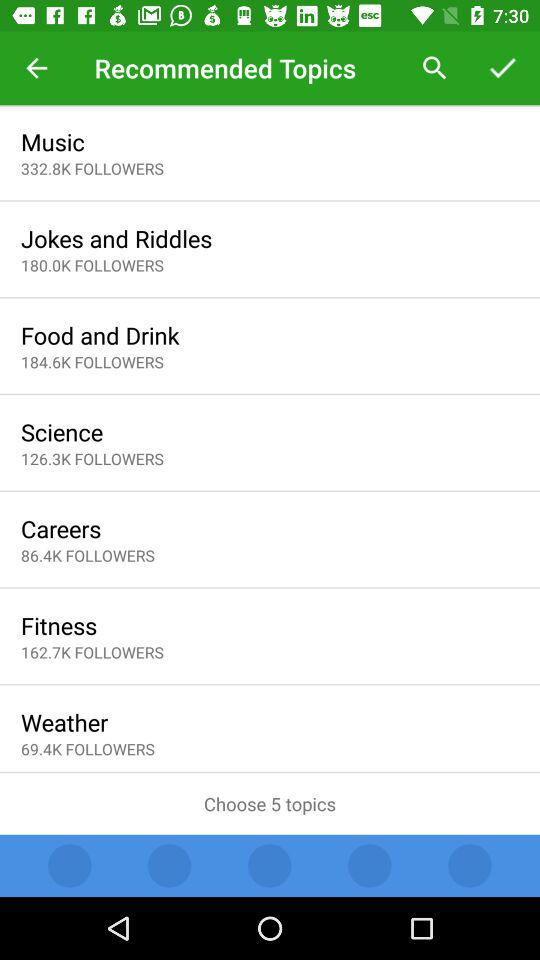What is the total number of followers of "Music"? The total number of followers of "Music" is 332,800. 